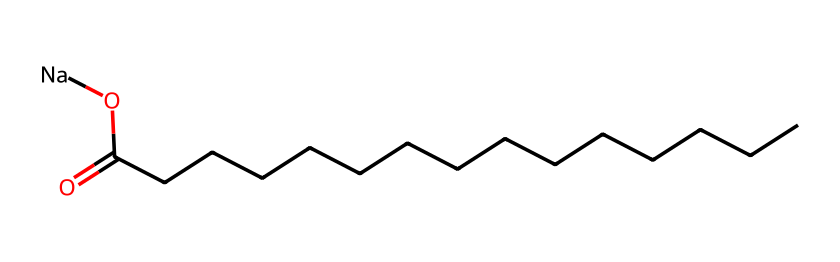What is the total number of carbon atoms in this chemical? By analyzing the SMILES representation, we can see that "CCCCCCCCCCCCCCC" indicates a straight-chain hydrocarbon with 15 carbon atoms.
Answer: 15 What type of functional group is present in this chemical? In the SMILES, the presence of "C(=O)O" indicates a carboxylic acid group due to the carbonyl (C=O) and hydroxyl (OH) components connected to the carbon chain.
Answer: carboxylic acid How many sodium atoms are present in the chemical? The SMILES notation includes "[Na]", which indicates the presence of one sodium atom as a counterion to the carboxylic acid group.
Answer: 1 What is the role of the sodium in this chemical? Sodium acts as a counterion to the carboxylate ion formed from the deprotonation of the carboxylic acid, enhancing the solubility of the surfactant in water.
Answer: counterion What property does this chemical likely enhance in hypoallergenic hand soaps? The presence of a long hydrophobic carbon chain combined with a hydrophilic ionic end makes it effective for reducing surface tension, allowing better cleaning properties while being gentle on the skin.
Answer: cleansing Why is this chemical classified as a surfactant? Surfactants are characterized by having both hydrophilic (water-attracting) and hydrophobic (water-repelling) parts, which is evident in the molecule's structure with the long carbon chain (hydrophobic) and the carboxylate group (hydrophilic).
Answer: amphiphilic 